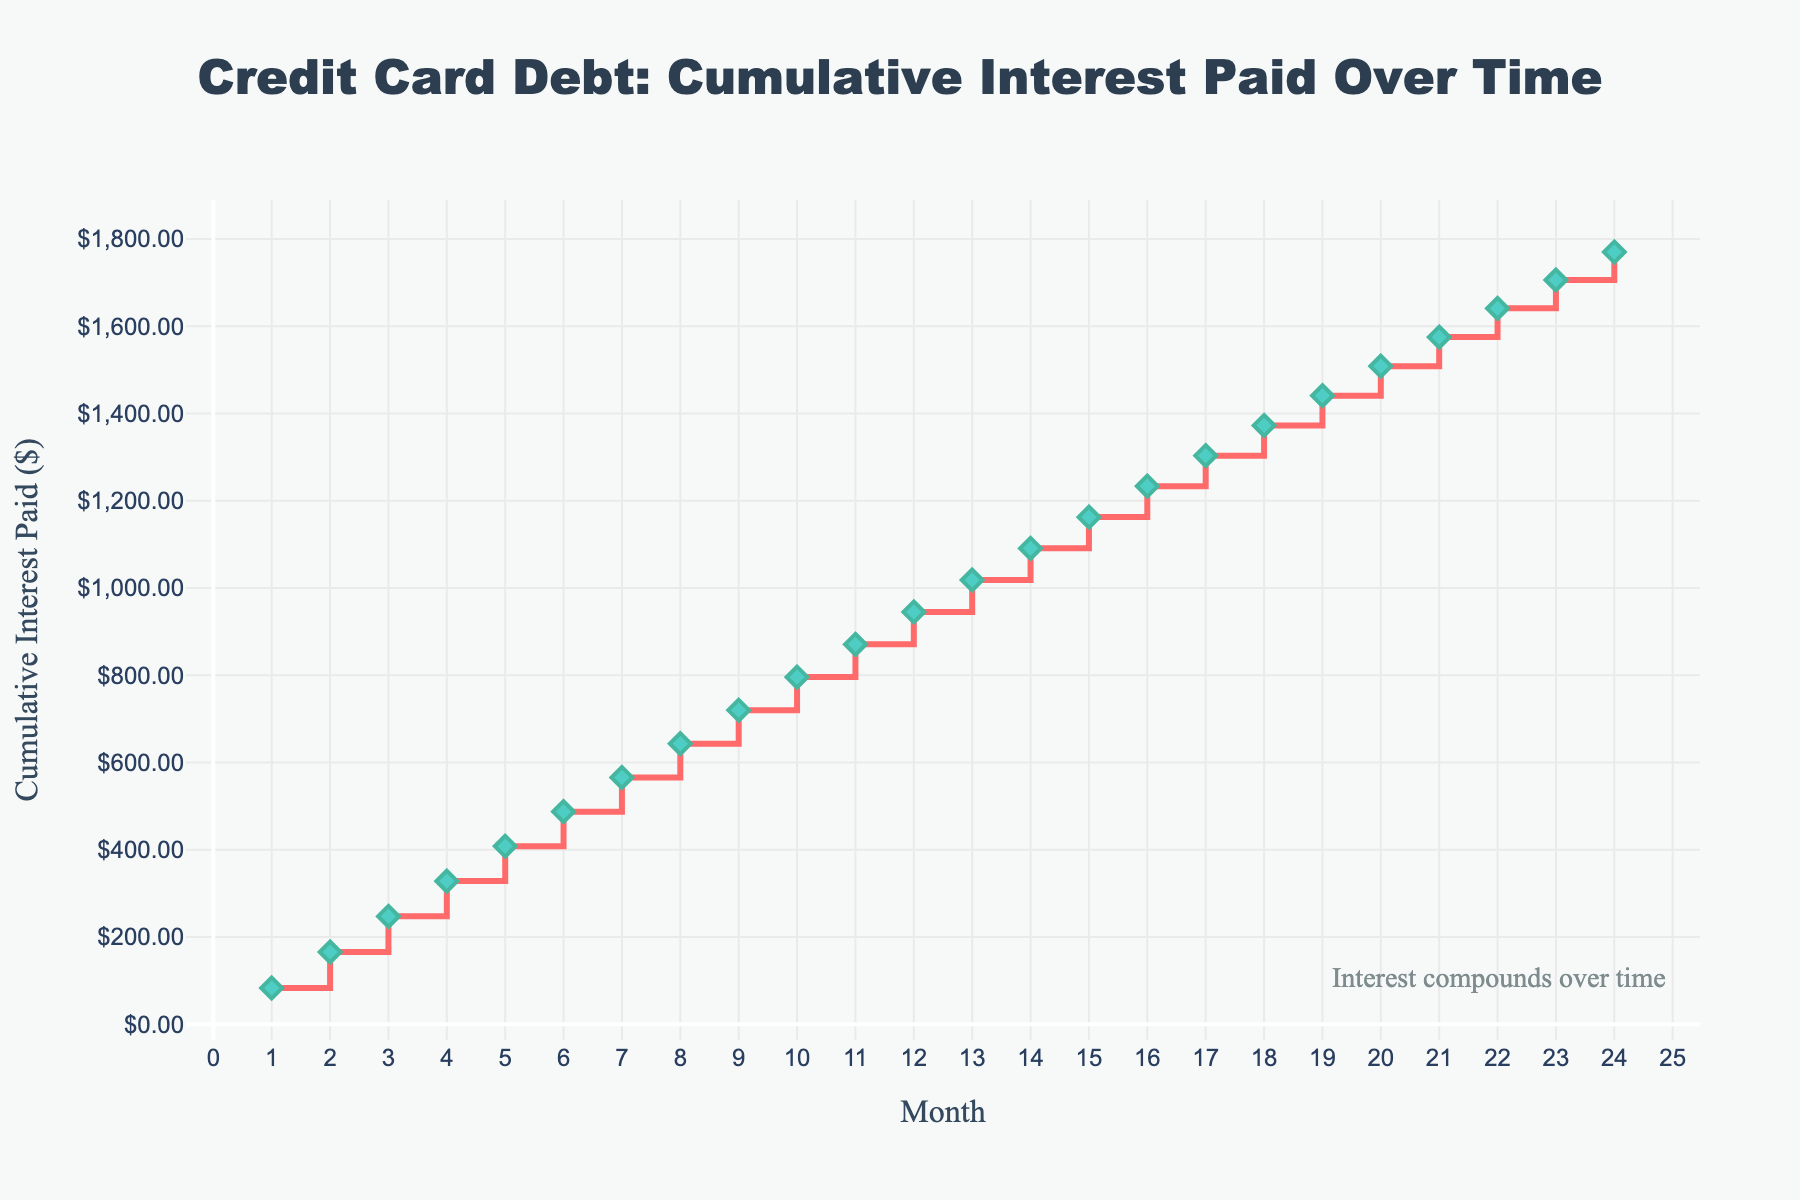What is the title of the figure? The title is located at the top of the plot and is centered with a larger font size. It states what the entire figure represents, which is the overall context of the visual data.
Answer: Credit Card Debt: Cumulative Interest Paid Over Time How many months are displayed in the figure? The x-axis represents the months, and they are marked from 1 to 24. By counting these ticks, we can determine the total number of months displayed.
Answer: 24 What is the cumulative interest paid by the end of 12 months? Locate the point on the graph corresponding to the 12th month on the x-axis and read the corresponding cumulative interest paid from the y-axis.
Answer: $945.00 What colors are used for the line and markers for cumulative interest paid? The line color is given a red hue, and the markers are in a different color with diamonds that are distinctive from the line. The explanation mentions "#FF6B6B" for the line and "#4ECDC4" for the markers.
Answer: Red (line) and Teal (markers) At which month do cumulative interest payments exceed $1000? Find the point on the graph where the cumulative interest paid curve crosses the $1000 mark on the y-axis and identify the corresponding month on the x-axis.
Answer: Month 13 What is the total amount of interest paid by the end of 24 months? Find the value on the y-axis corresponding to month 24 on the x-axis. This will give the cumulative interest paid up to 24 months.
Answer: $1770.00 In which month is the cumulative interest paid almost exactly halfway between $500 and $1000? First, calculate the halfway point between $500 and $1000, which is $750. Then, find the closest month where the cumulative interest paid is around $750 on the y-axis.
Answer: Month 10 (approximately $795.83) What is the difference in cumulative interest paid between month 6 and month 12? Read the cumulative interest paid on the y-axis for both months 6 and 12, and calculate the difference. Values are $487.50 and $945.00, respectively. Subtract the former from the latter.
Answer: $457.50 By how much does the interest paid decrease each month? Observe consecutive monthly interest paid from the table data provided. It decreases consistently by $0.83 each month.
Answer: $0.83 Describe the trend of the cumulative interest paid over the 24 months depicted. The cumulative interest paid over time shows a continuously increasing trend, represented as a stair-stepped line on the plot that moves upward every month without decreasing.
Answer: Continuously increasing 